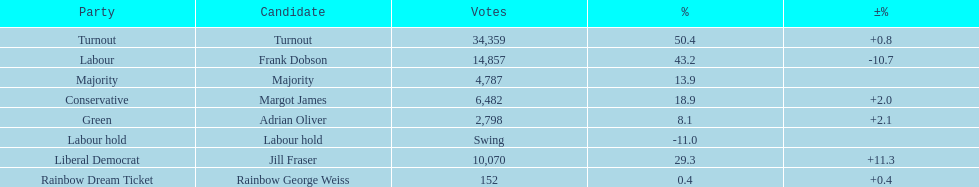How many votes did both the conservative party and the rainbow dream ticket party receive? 6634. 